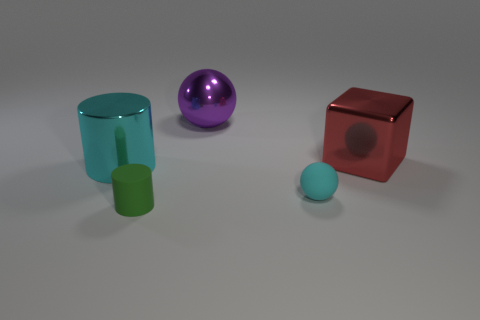Is the shape of the big purple shiny thing the same as the red object?
Make the answer very short. No. Is there any other thing of the same color as the small rubber ball?
Your answer should be compact. Yes. Does the red thing have the same shape as the matte object left of the purple metallic object?
Offer a terse response. No. The sphere in front of the large cylinder that is left of the big thing behind the red metallic cube is what color?
Ensure brevity in your answer.  Cyan. Is there anything else that has the same material as the green object?
Offer a terse response. Yes. There is a object in front of the matte sphere; is its shape the same as the cyan metallic thing?
Ensure brevity in your answer.  Yes. What is the big cyan cylinder made of?
Keep it short and to the point. Metal. There is a metallic object that is on the left side of the cylinder that is right of the cyan object on the left side of the green matte cylinder; what shape is it?
Your answer should be compact. Cylinder. What number of other things are the same shape as the purple thing?
Provide a succinct answer. 1. There is a tiny matte cylinder; is it the same color as the thing that is on the right side of the cyan matte sphere?
Provide a succinct answer. No. 